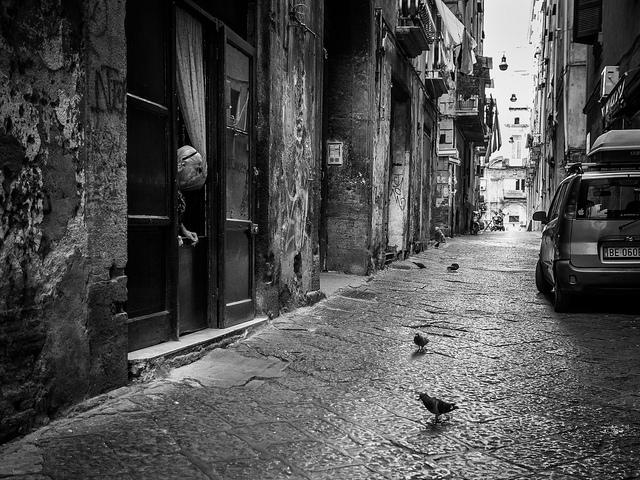What type of vehicle is in the picture?
Concise answer only. Van. What animal can be seen?
Concise answer only. Bird. Is a car parked on the street?
Give a very brief answer. Yes. How many cars are seen?
Quick response, please. 1. Is this a black and white photo?
Write a very short answer. Yes. 